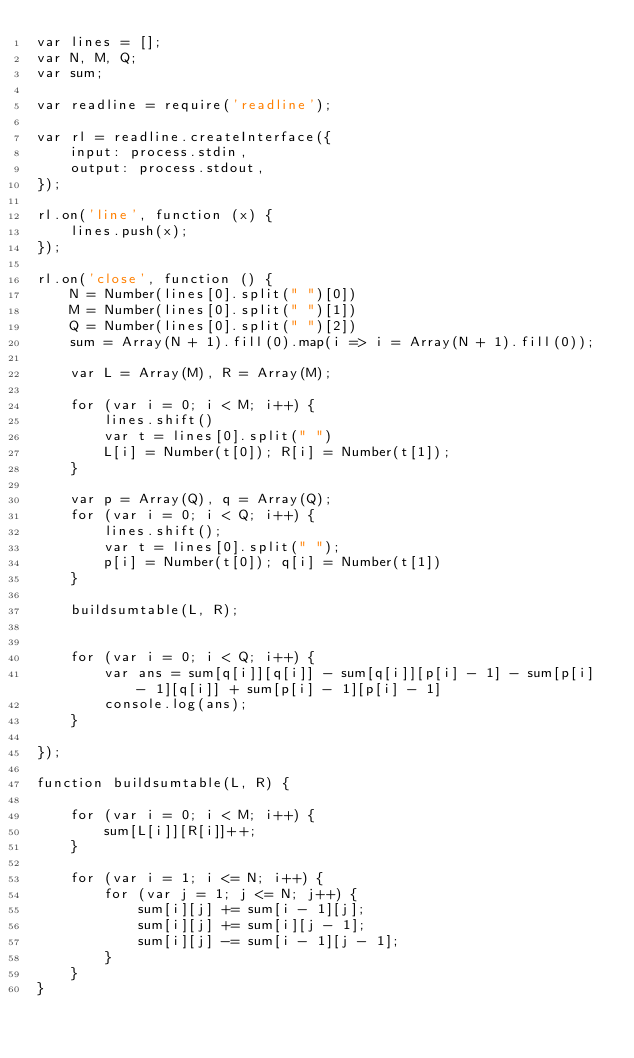Convert code to text. <code><loc_0><loc_0><loc_500><loc_500><_JavaScript_>var lines = [];
var N, M, Q;
var sum;

var readline = require('readline');

var rl = readline.createInterface({
    input: process.stdin,
    output: process.stdout,
});

rl.on('line', function (x) {
    lines.push(x);
});

rl.on('close', function () {
    N = Number(lines[0].split(" ")[0])
    M = Number(lines[0].split(" ")[1])
    Q = Number(lines[0].split(" ")[2])
    sum = Array(N + 1).fill(0).map(i => i = Array(N + 1).fill(0));

    var L = Array(M), R = Array(M);

    for (var i = 0; i < M; i++) {
        lines.shift()
        var t = lines[0].split(" ")
        L[i] = Number(t[0]); R[i] = Number(t[1]);
    }

    var p = Array(Q), q = Array(Q);
    for (var i = 0; i < Q; i++) {
        lines.shift();
        var t = lines[0].split(" ");
        p[i] = Number(t[0]); q[i] = Number(t[1])
    }

    buildsumtable(L, R);


    for (var i = 0; i < Q; i++) {
        var ans = sum[q[i]][q[i]] - sum[q[i]][p[i] - 1] - sum[p[i] - 1][q[i]] + sum[p[i] - 1][p[i] - 1]
        console.log(ans);
    }

});

function buildsumtable(L, R) {

    for (var i = 0; i < M; i++) {
        sum[L[i]][R[i]]++;
    }

    for (var i = 1; i <= N; i++) {
        for (var j = 1; j <= N; j++) {
            sum[i][j] += sum[i - 1][j];
            sum[i][j] += sum[i][j - 1];
            sum[i][j] -= sum[i - 1][j - 1];
        }
    }
}</code> 